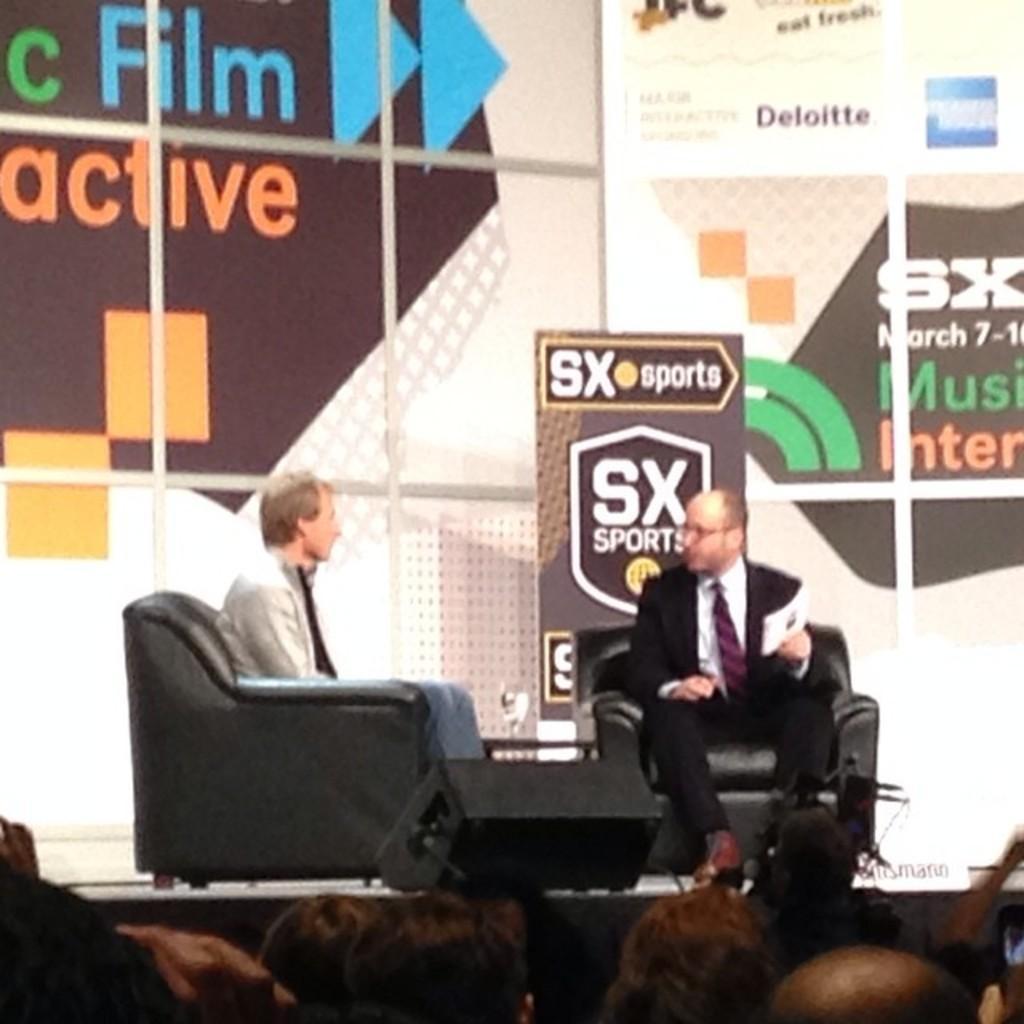Could you give a brief overview of what you see in this image? In this picture we can see man wore blazer, tie holding paper in his hand sitting on chair and beside him person is also sitting on chair and in the background we can see banner, wall and in front of them we can see a crowd of people. 